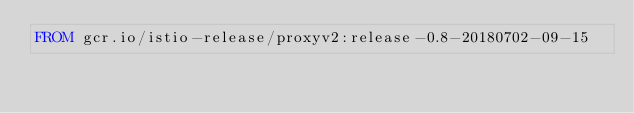<code> <loc_0><loc_0><loc_500><loc_500><_Dockerfile_>FROM gcr.io/istio-release/proxyv2:release-0.8-20180702-09-15
</code> 